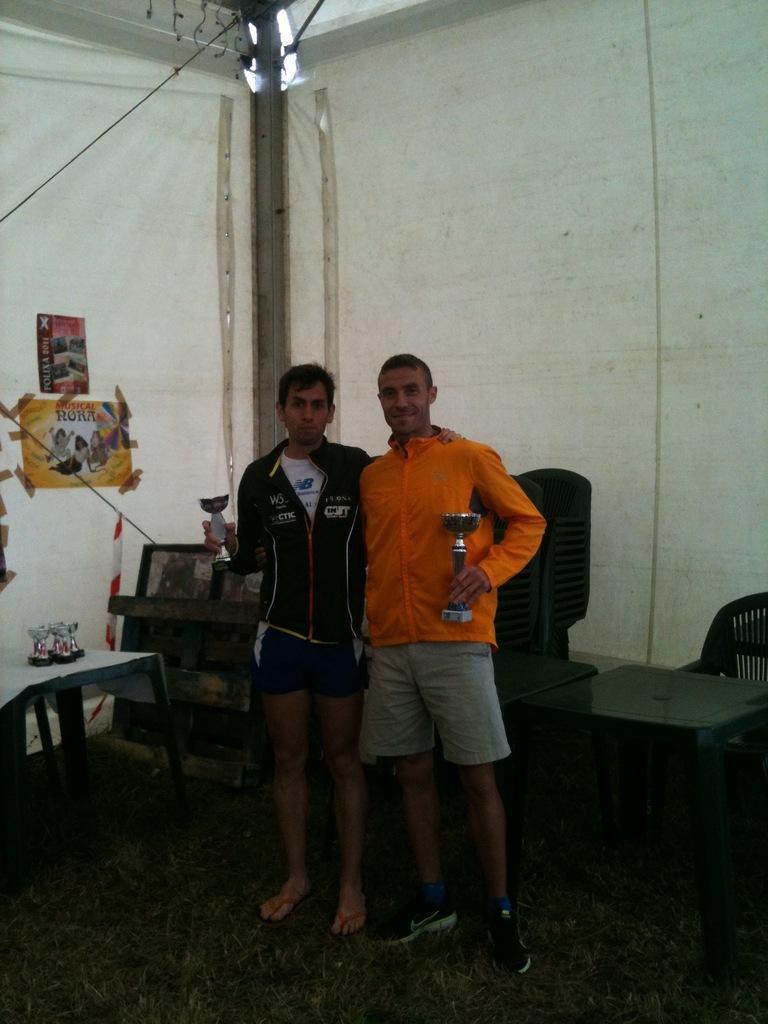Could you give a brief overview of what you see in this image? In this I can see two men are standing and also smiling, they wore coats, shorts. On the left side there is a paper stick to the wall, on the right side there is a chair and table. 